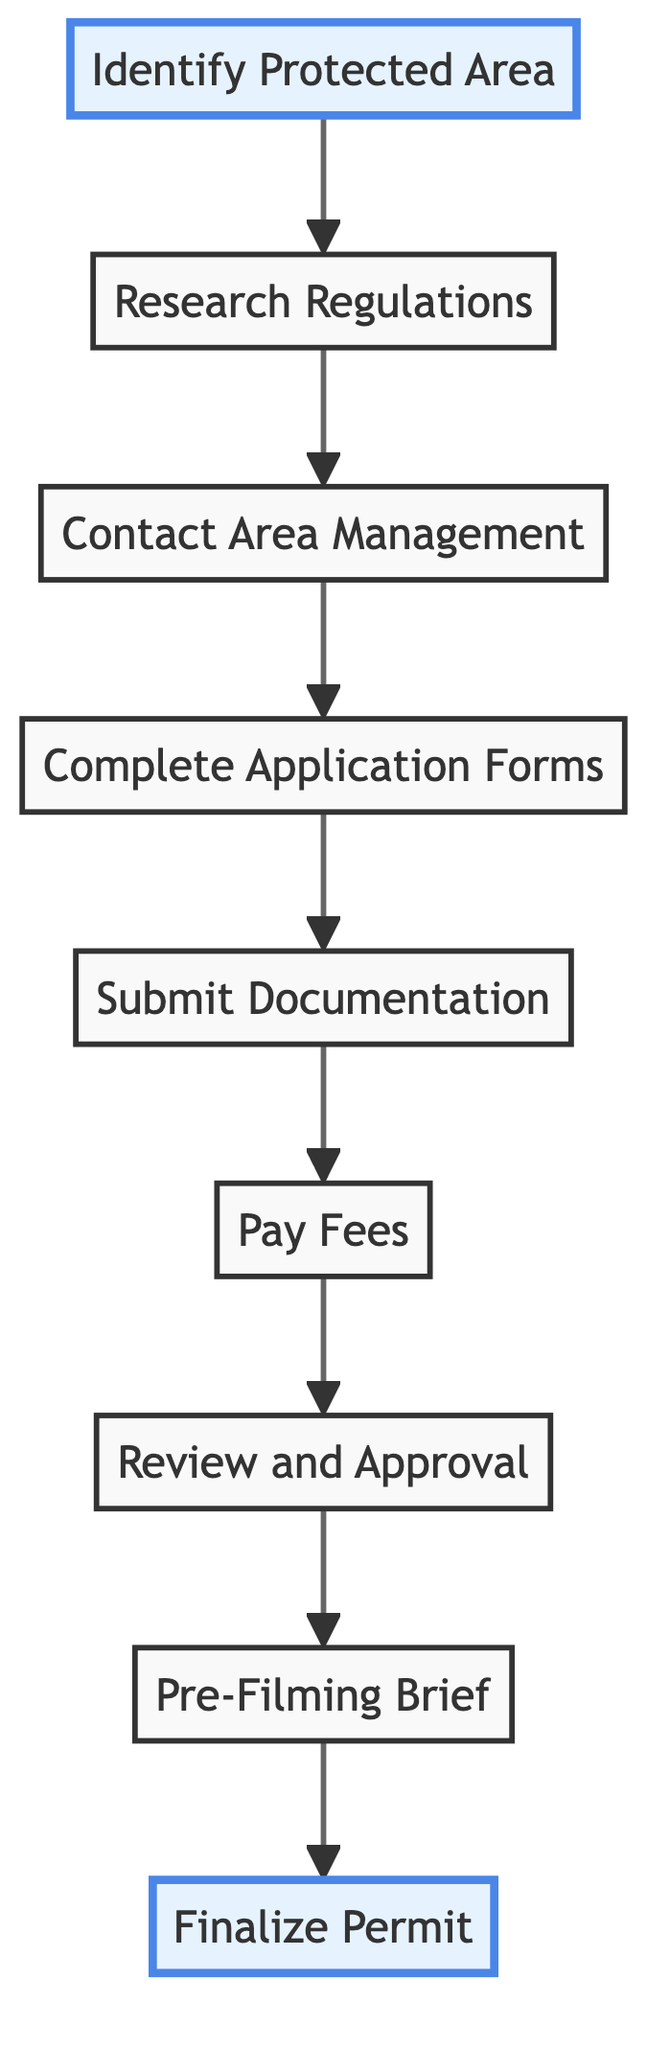What is the first step in securing filming permits? The first step is "Identify Protected Area". This is the starting point of the flow chart, indicating that determining where you intend to film is crucial before proceeding.
Answer: Identify Protected Area How many total steps are in the diagram? To determine the total steps, you can count the numbered nodes in the flow chart, which are 9 steps.
Answer: 9 What is the last step in the process? The last step is "Finalize Permit". This occurs after meeting all requirements and receiving the finalized permitting document.
Answer: Finalize Permit Which step follows "Research Regulations"? Based on the flow of the diagram, "Contact Area Management" is the immediate step following "Research Regulations".
Answer: Contact Area Management What must be done after "Submit Documentation"? The next action after "Submit Documentation" is "Pay Fees", indicating that payment is a subsequent requirement in the permitting process.
Answer: Pay Fees What phase occurs after the "Review and Approval"? The step that follows "Review and Approval" is "Pre-Filming Brief", which signifies the need for any necessary orientation sessions before filming begins.
Answer: Pre-Filming Brief How does one finalize the filming permit? To finalize the filming permit, one must complete all requirements, get the application approved, and subsequently receive the finalized permit document.
Answer: Meet requirements and get approval What is the primary purpose of "Complete Application Forms"? The primary purpose is to request a filming permit by filling out the required forms, which is a necessary part of the application process.
Answer: Request filming permit Which step involves understanding filming restrictions? "Pre-Filming Brief" involves understanding the do’s and don’ts while filming, ensuring you are aware of the regulations in the protected area.
Answer: Pre-Filming Brief 